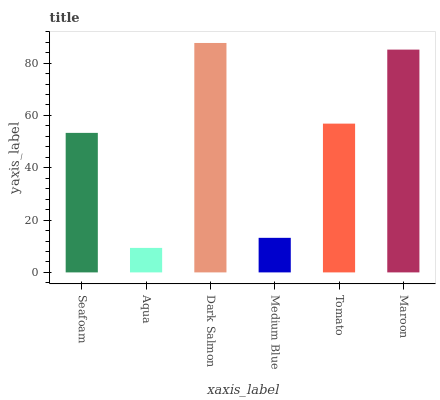Is Aqua the minimum?
Answer yes or no. Yes. Is Dark Salmon the maximum?
Answer yes or no. Yes. Is Dark Salmon the minimum?
Answer yes or no. No. Is Aqua the maximum?
Answer yes or no. No. Is Dark Salmon greater than Aqua?
Answer yes or no. Yes. Is Aqua less than Dark Salmon?
Answer yes or no. Yes. Is Aqua greater than Dark Salmon?
Answer yes or no. No. Is Dark Salmon less than Aqua?
Answer yes or no. No. Is Tomato the high median?
Answer yes or no. Yes. Is Seafoam the low median?
Answer yes or no. Yes. Is Maroon the high median?
Answer yes or no. No. Is Maroon the low median?
Answer yes or no. No. 